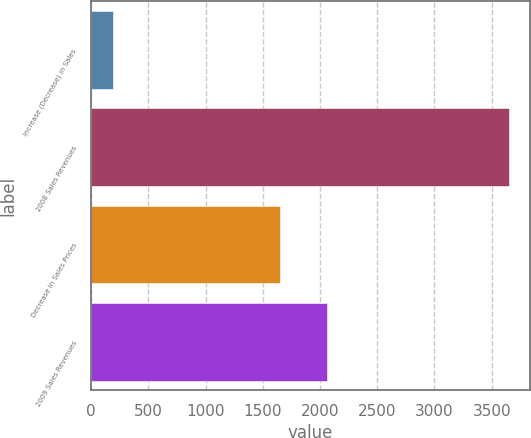<chart> <loc_0><loc_0><loc_500><loc_500><bar_chart><fcel>Increase (Decrease) in Sales<fcel>2008 Sales Revenues<fcel>Decrease in Sales Prices<fcel>2009 Sales Revenues<nl><fcel>188<fcel>3651<fcel>1647<fcel>2060<nl></chart> 